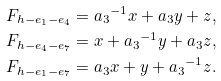<formula> <loc_0><loc_0><loc_500><loc_500>F _ { h - e _ { 1 } - e _ { 4 } } & = { a _ { 3 } } ^ { - 1 } x + { a _ { 3 } } y + z , \\ F _ { h - e _ { 4 } - e _ { 7 } } & = x + { a _ { 3 } } ^ { - 1 } y + { a _ { 3 } } z , \\ F _ { h - e _ { 1 } - e _ { 7 } } & = { a _ { 3 } } x + y + { a _ { 3 } } ^ { - 1 } z .</formula> 